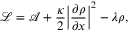<formula> <loc_0><loc_0><loc_500><loc_500>\mathcal { L } = \mathcal { A } + \frac { \kappa } { 2 } { \left | \frac { \partial \rho } { \partial x } \right | } ^ { 2 } - \lambda \rho ,</formula> 